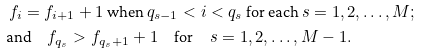<formula> <loc_0><loc_0><loc_500><loc_500>& \text { ${f}_{i} = {f}_{i+1}+1 $ when $ q_{s-1} < i < q_{s} $ for each $ s=1,2,\dots, M; $ } \\ & \text {and} \quad { f } _ { q _ { s } } > { f } _ { q _ { s } + 1 } + 1 \quad \text {for} \quad s = 1 , 2 , \dots , M - 1 .</formula> 